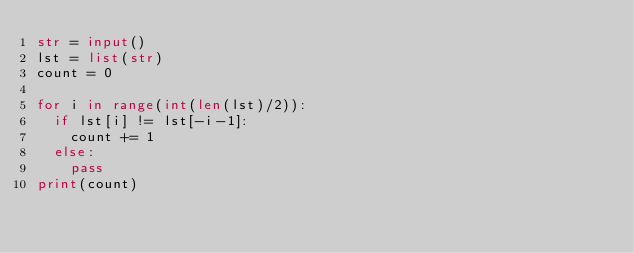Convert code to text. <code><loc_0><loc_0><loc_500><loc_500><_Python_>str = input()
lst = list(str)
count = 0

for i in range(int(len(lst)/2)):
  if lst[i] != lst[-i-1]:
    count += 1
  else:
    pass
print(count)
</code> 